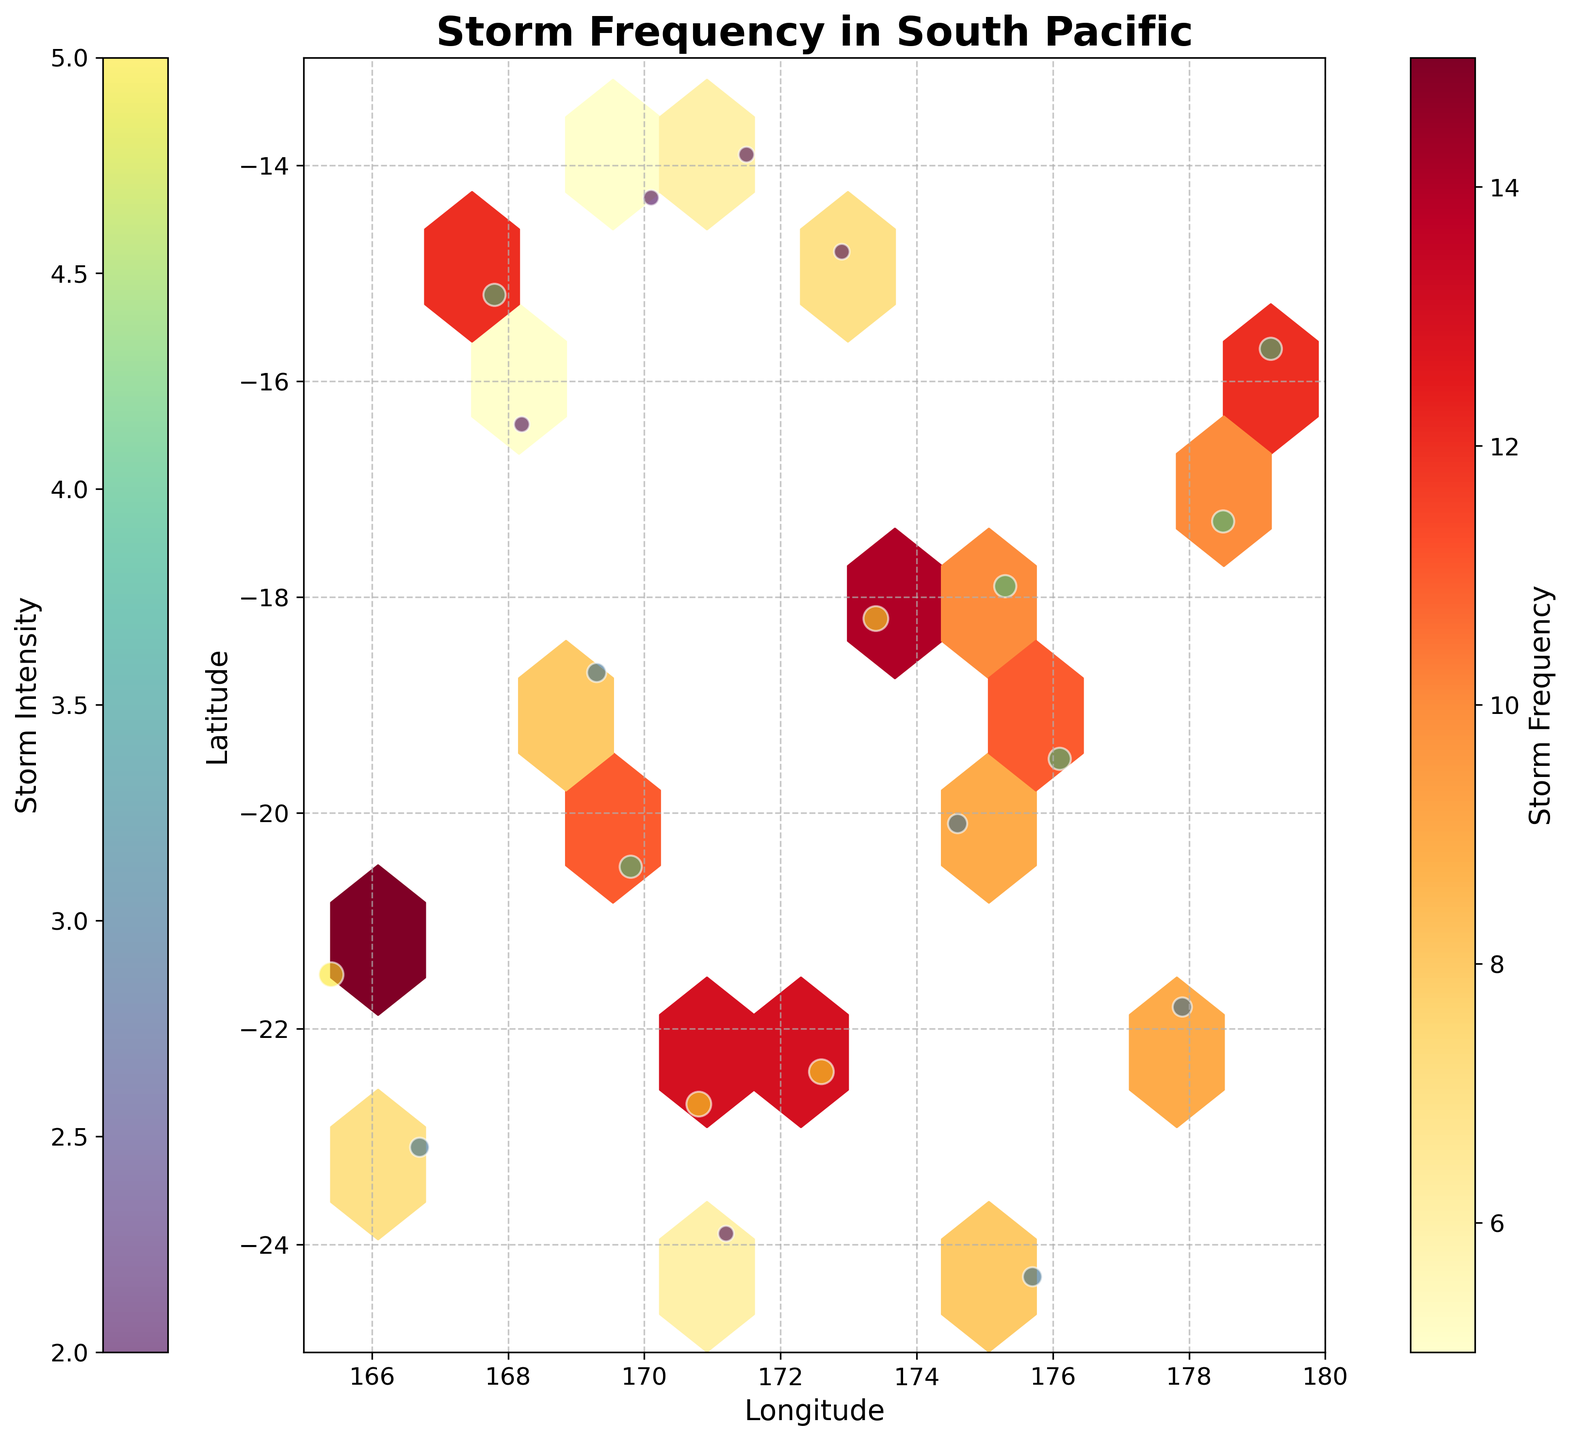What is the title of the plot? The title is typically located at the top of the plot. Reading the title helps understand the focus of the plot. In this case, the title should be "Storm Frequency in South Pacific".
Answer: Storm Frequency in South Pacific What does the colorbar on the right represent? Colorbars are typically used to provide a reference for interpreting color scales in plots. Here, the colorbar on the right would represent the storm frequency as indicated by the label next to it.
Answer: Storm Frequency What is the range of longitudes shown in the plot? Longitude values run horizontally on the plot, and we can identify the range by looking at the x-axis. The axis limits are set between 165 and 180.
Answer: 165 to 180 Which latitude has the highest storm intensity represented by the scatter plot? The scatter plot uses color shading and size to represent intensity; higher intensity will typically have bigger or darker points. By comparing these, one can deduce that the latitude with the highest intensity is likely at -21.5 based on the data.
Answer: -21.5 How many data points are within the longitude range of 170 to 175? By visually inspecting the scatter plot within the specified longitude range, we can count the number of points that are present between 170 and 175. There appear to be 5 data points.
Answer: 5 Does a higher frequency of storms correlate with specific longitudes or latitudes? Analyzing the hexbin plot will show denser hexagonal bins in areas with higher frequency. The plot is denser between longitudes 170-175 and latitudes -20 to -15.
Answer: Yes, between 170-175 longitude and -20 to -15 latitude What is the label of the y-axis on the plot? Axis labels are given to help identify what is being measured along each axis. For the y-axis, the label is "Latitude".
Answer: Latitude Which area of the plot shows the least storm activity? Areas with lighter colors or fewer hexagons indicate less storm activity. This information can be found by looking for the less dense or lighter regions in the plot. The region around longitude 179 and latitude -15 shows the least storm activity.
Answer: Around 179 longitude and -15 latitude Compare the storm frequency around latitude -20: Is it higher, lower, or about the same when moving from longitude 165 to 180? Observe the color and density variations around latitude -20 across the longitudes. The frequency appears to vary but remains relatively high overall compared to some other areas.
Answer: About the same What pattern, if any, can be observed about storm intensity across different latitudes? By examining the scatter plot and noticing the intensity represented by the color and size variations, one can see that higher intensities tend to appear in mid-range latitudes (e.g., -20 to -15) rather than at extremes.
Answer: Higher in mid-range latitudes (-20 to -15) 